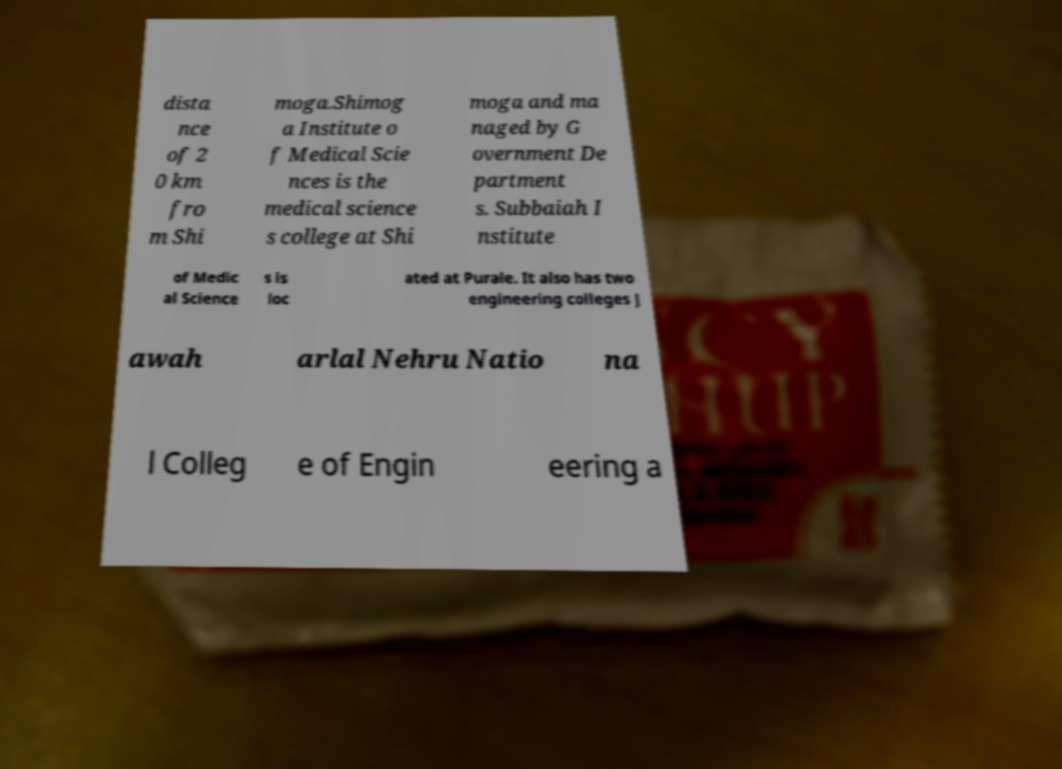Please read and relay the text visible in this image. What does it say? dista nce of 2 0 km fro m Shi moga.Shimog a Institute o f Medical Scie nces is the medical science s college at Shi moga and ma naged by G overnment De partment s. Subbaiah I nstitute of Medic al Science s is loc ated at Purale. It also has two engineering colleges J awah arlal Nehru Natio na l Colleg e of Engin eering a 